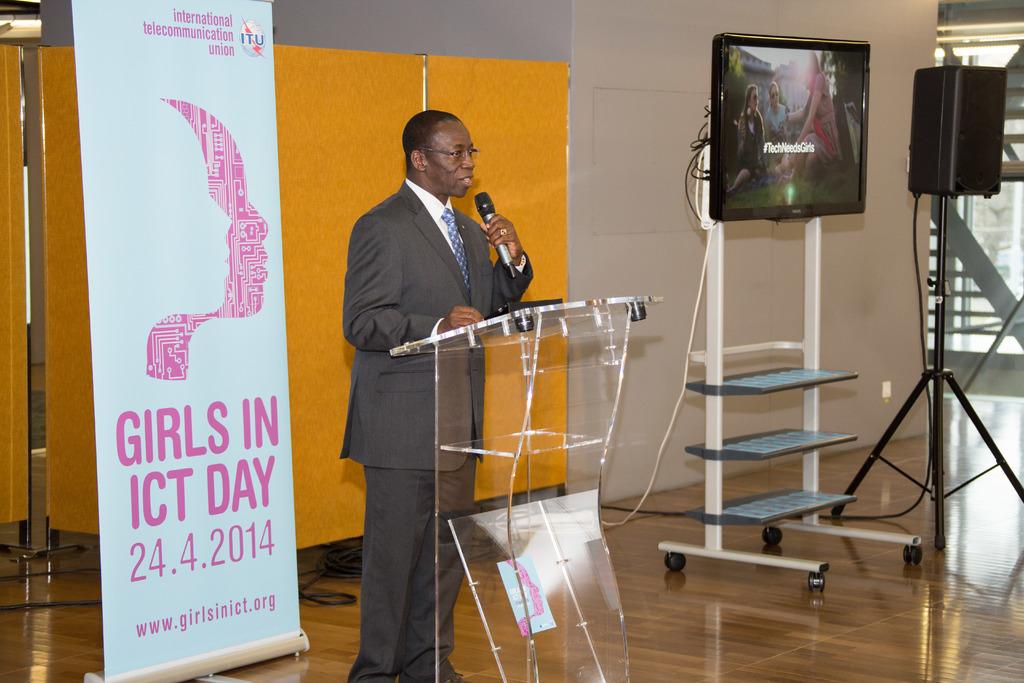What day is mentioned on the sign?
Offer a very short reply. Girls in ict day. What date is girls in ict day?
Your response must be concise. 24.4.2014. 